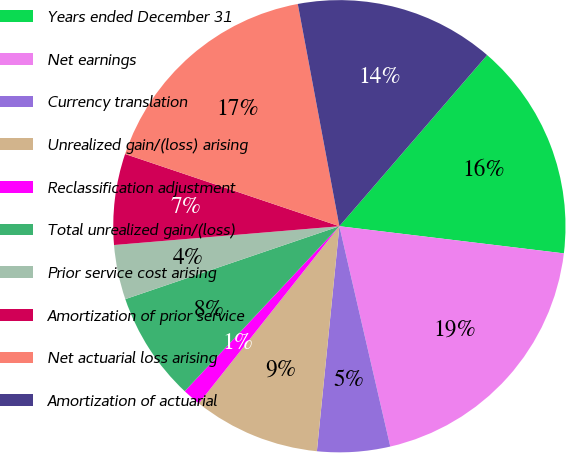Convert chart to OTSL. <chart><loc_0><loc_0><loc_500><loc_500><pie_chart><fcel>Years ended December 31<fcel>Net earnings<fcel>Currency translation<fcel>Unrealized gain/(loss) arising<fcel>Reclassification adjustment<fcel>Total unrealized gain/(loss)<fcel>Prior service cost arising<fcel>Amortization of prior service<fcel>Net actuarial loss arising<fcel>Amortization of actuarial<nl><fcel>15.58%<fcel>19.47%<fcel>5.2%<fcel>9.09%<fcel>1.31%<fcel>7.79%<fcel>3.9%<fcel>6.5%<fcel>16.88%<fcel>14.28%<nl></chart> 